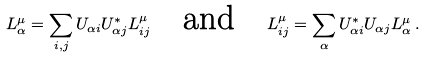<formula> <loc_0><loc_0><loc_500><loc_500>L ^ { \mu } _ { \alpha } = \sum _ { i , j } U _ { \alpha i } U ^ { * } _ { \alpha j } L ^ { \mu } _ { i j } \quad \text {and} \quad L ^ { \mu } _ { i j } = \sum _ { \alpha } U ^ { * } _ { \alpha i } U _ { \alpha j } L ^ { \mu } _ { \alpha } \, .</formula> 